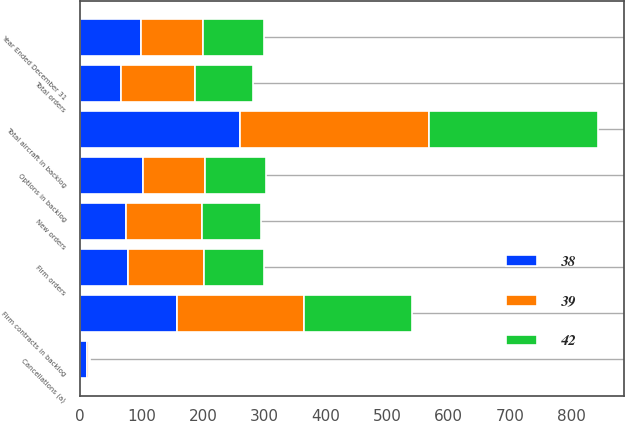Convert chart. <chart><loc_0><loc_0><loc_500><loc_500><stacked_bar_chart><ecel><fcel>Year Ended December 31<fcel>New orders<fcel>Firm orders<fcel>Cancellations (a)<fcel>Total orders<fcel>Firm contracts in backlog<fcel>Options in backlog<fcel>Total aircraft in backlog<nl><fcel>39<fcel>100<fcel>124<fcel>124<fcel>3<fcel>121<fcel>207<fcel>100<fcel>307<nl><fcel>42<fcel>100<fcel>96<fcel>97<fcel>2<fcel>95<fcel>175<fcel>100<fcel>275<nl><fcel>38<fcel>100<fcel>75<fcel>78<fcel>12<fcel>66<fcel>158<fcel>103<fcel>261<nl></chart> 